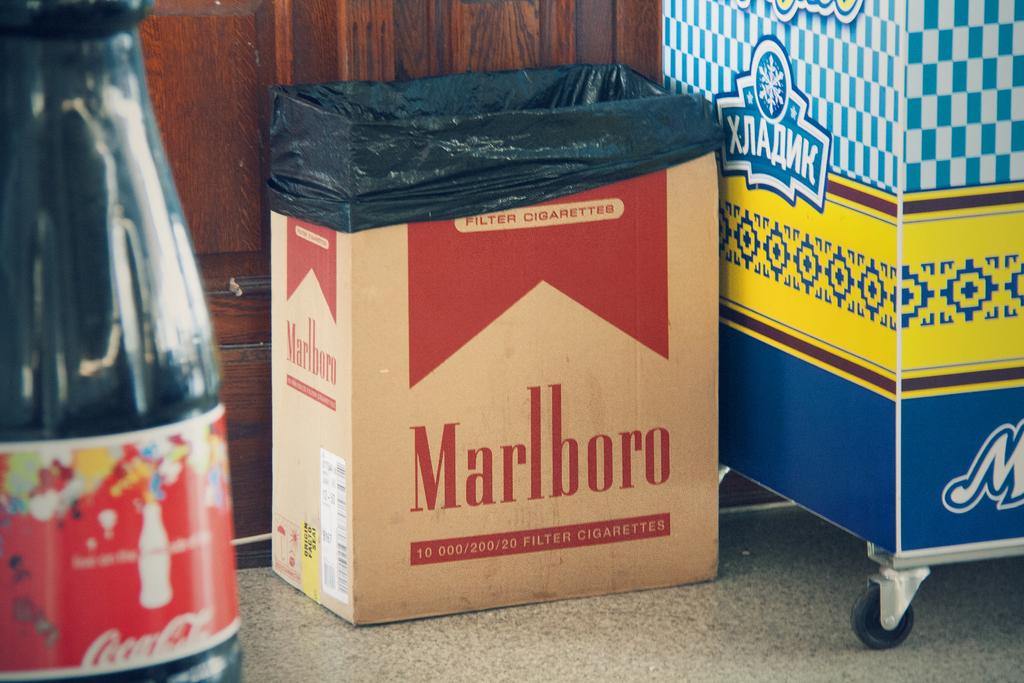What is the brand on the brown box?
Your answer should be very brief. Marlboro. What cigarette brand box is being used as a trash can?
Your response must be concise. Marlboro. 